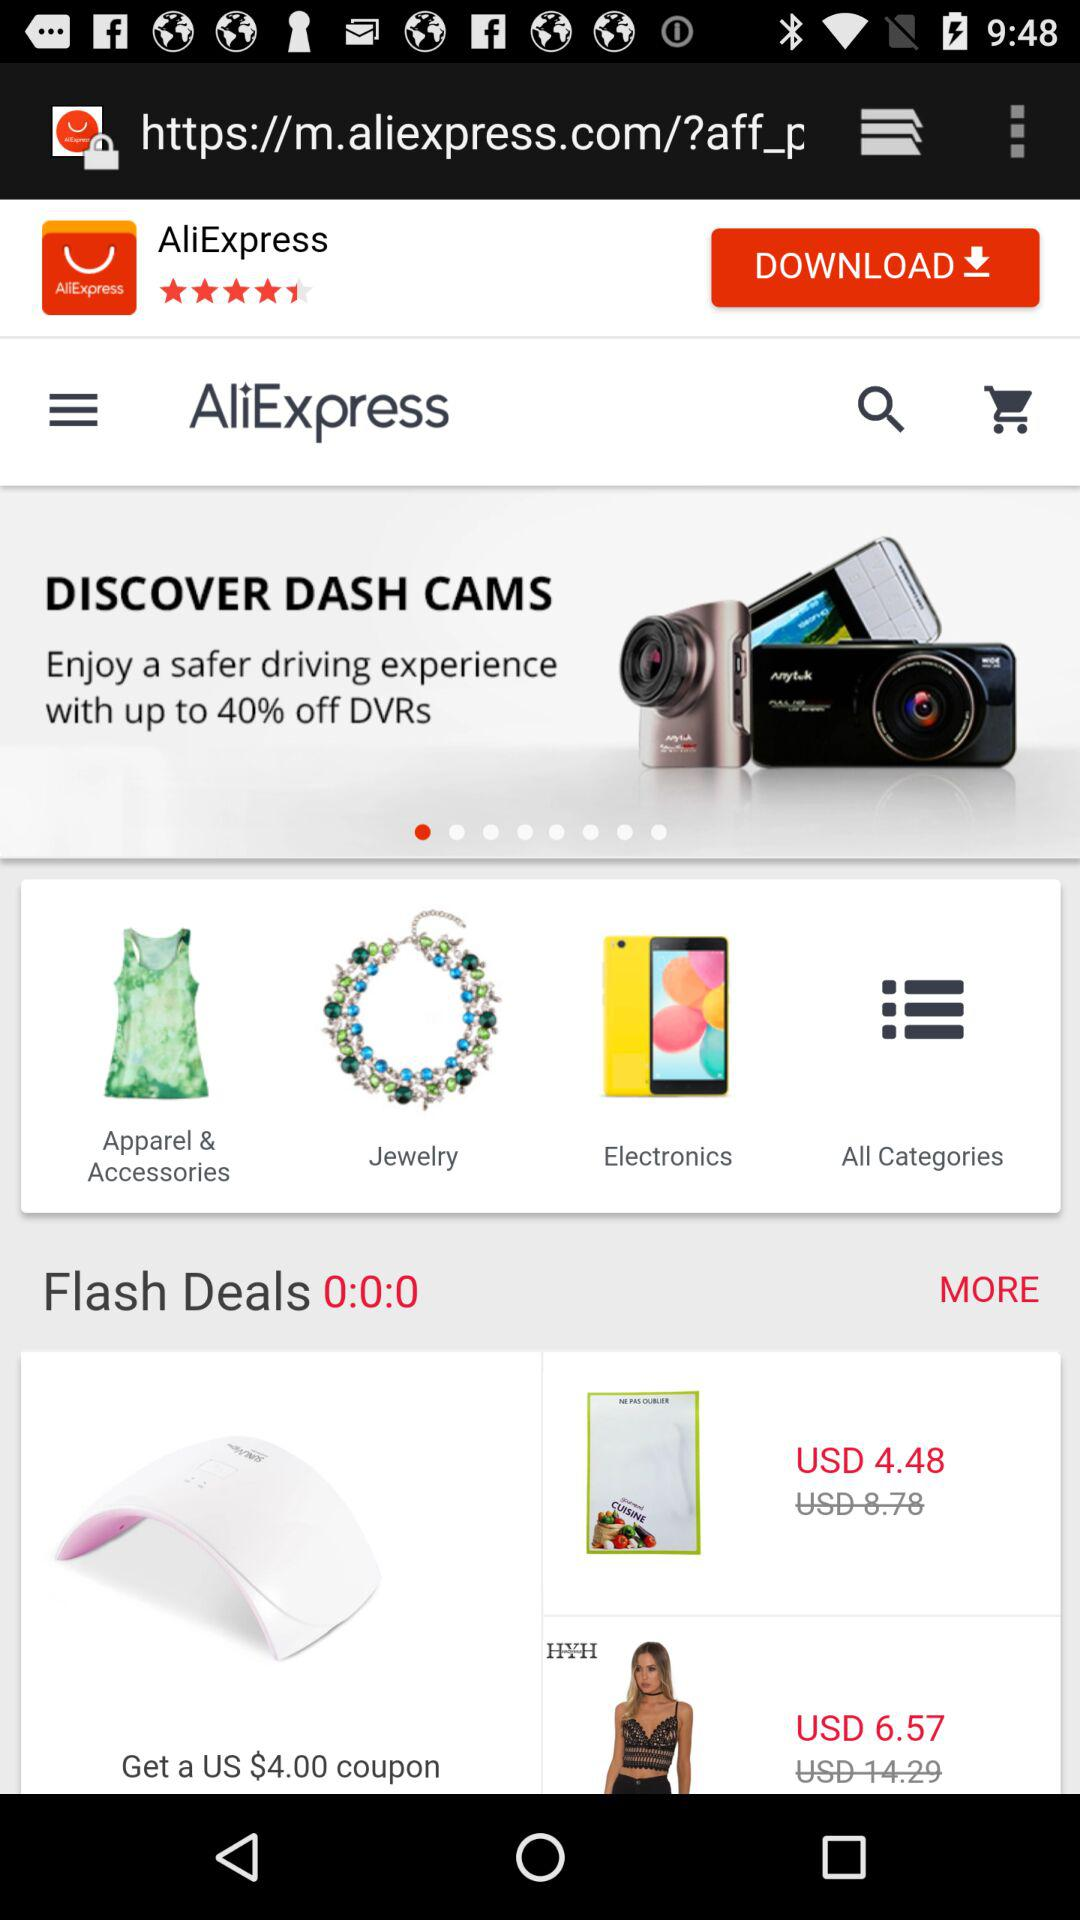How much is the discount on "DVRs"? The discount on "DVRs" is up to 40%. 